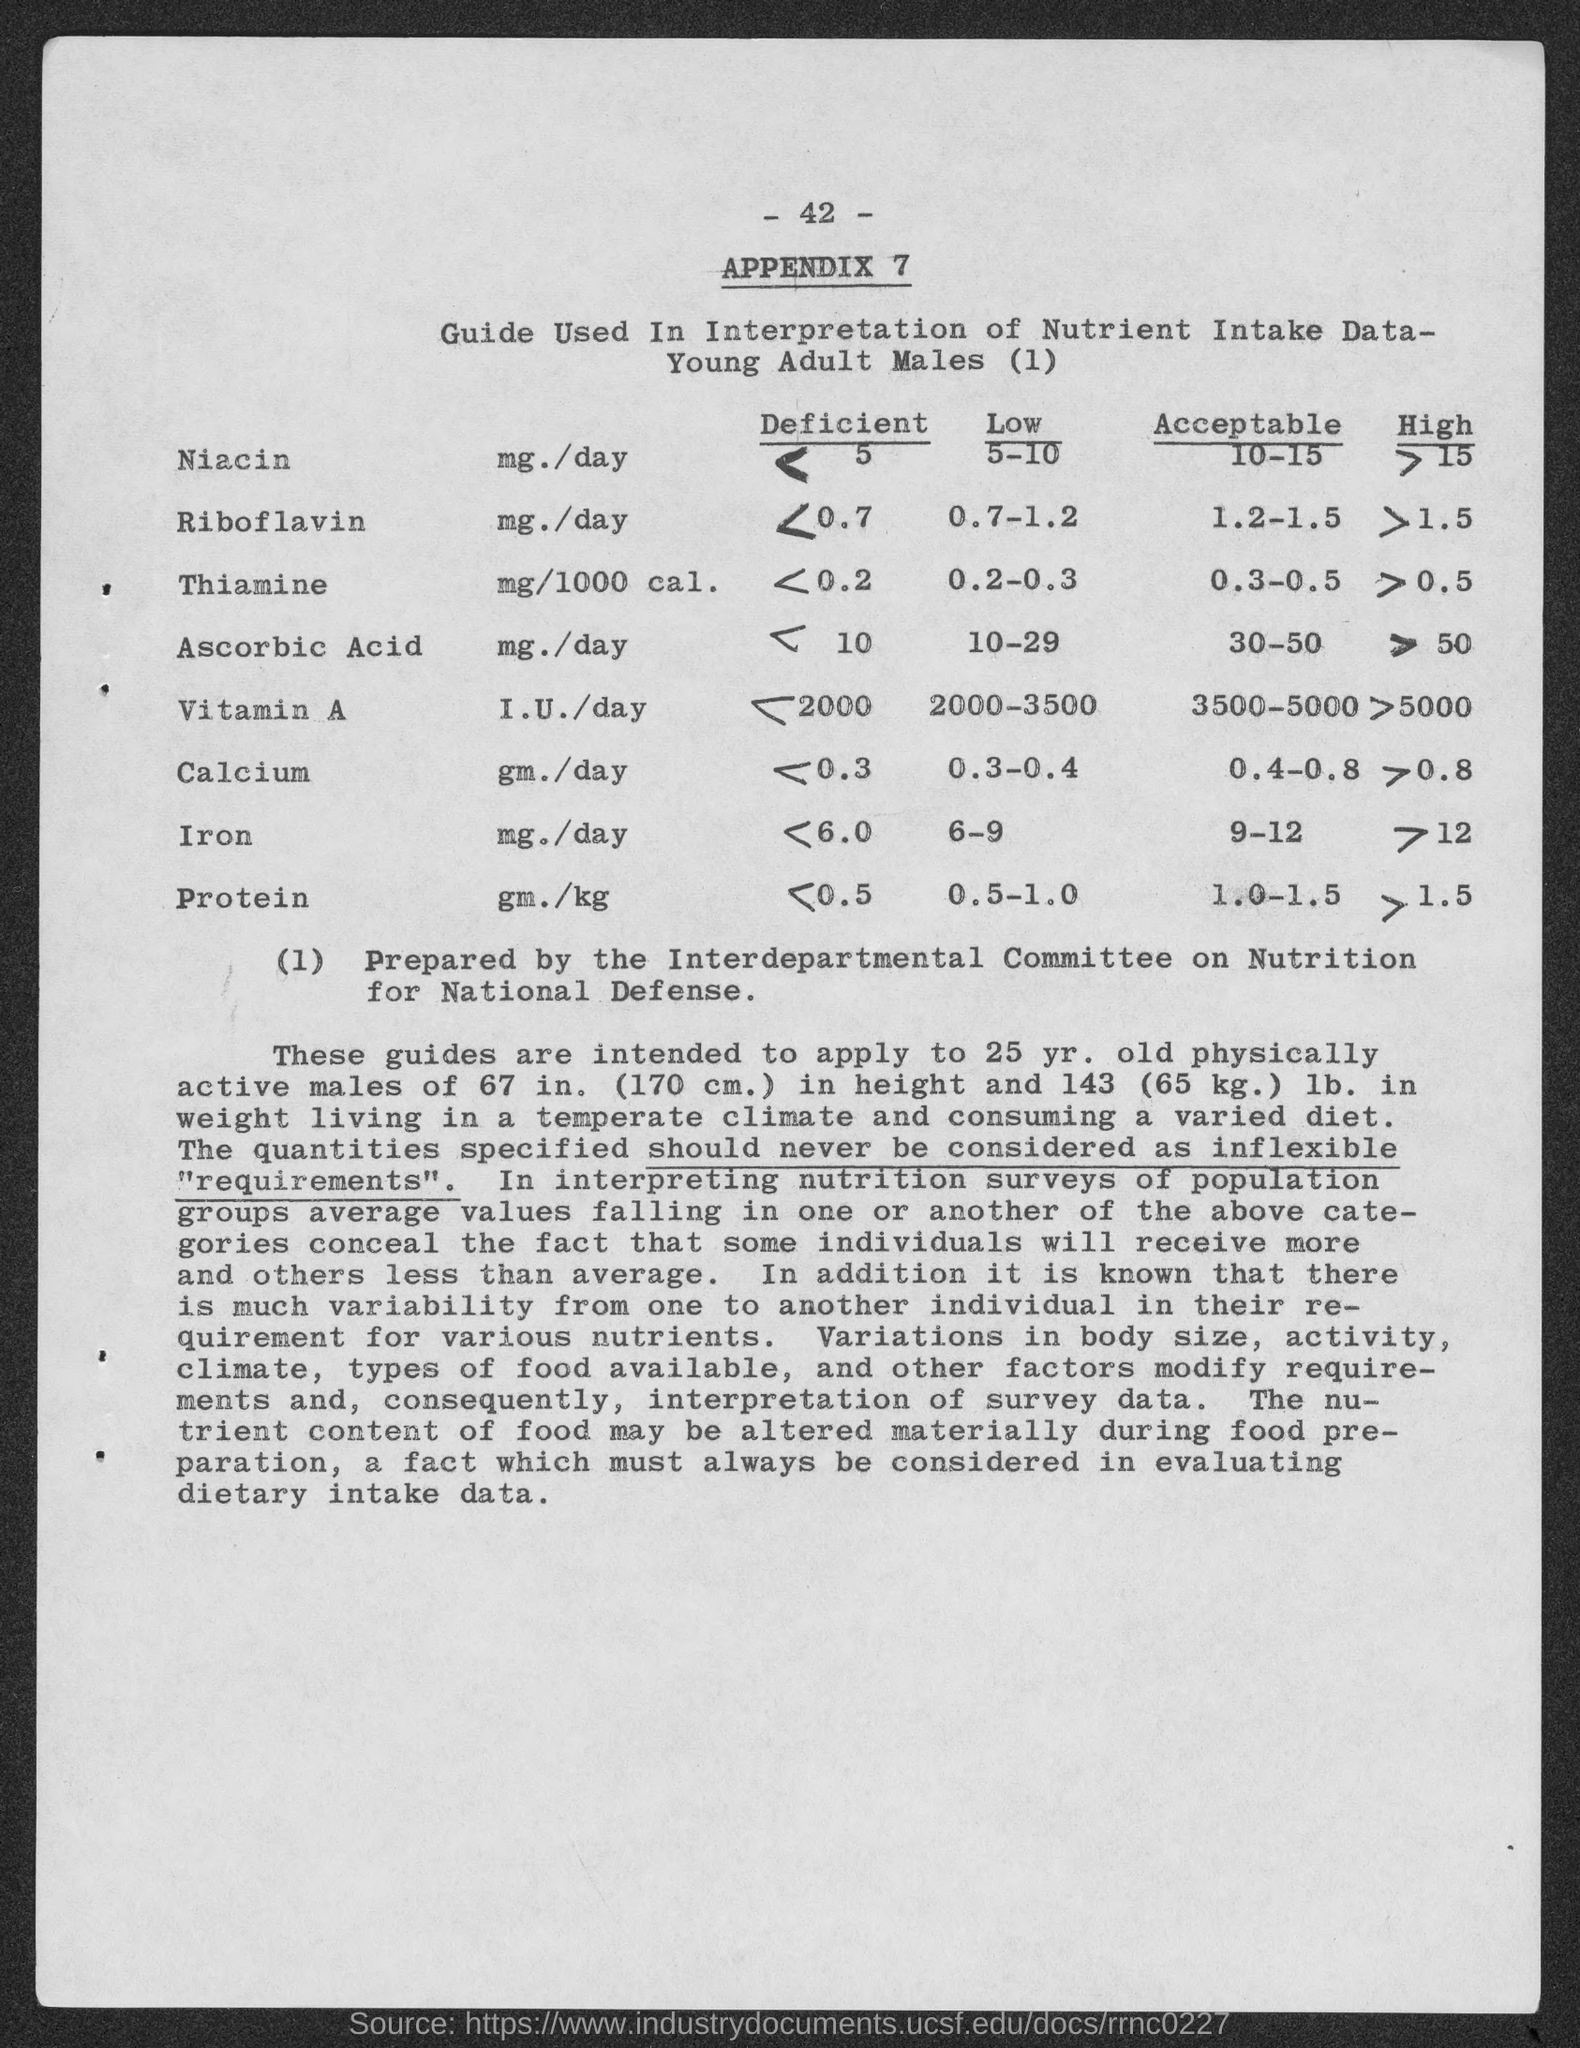What is the page number?
Provide a succinct answer. - 42 -. What is the appendix number?
Give a very brief answer. Appendix 7. What is the acceptable range of iron in the body of a male?
Your answer should be compact. 9-12. What is the acceptable range of protein in the body of a male?
Your answer should be very brief. 1.0-1.5. What is the acceptable range of niacin in the body of a male?
Make the answer very short. 10-15. 